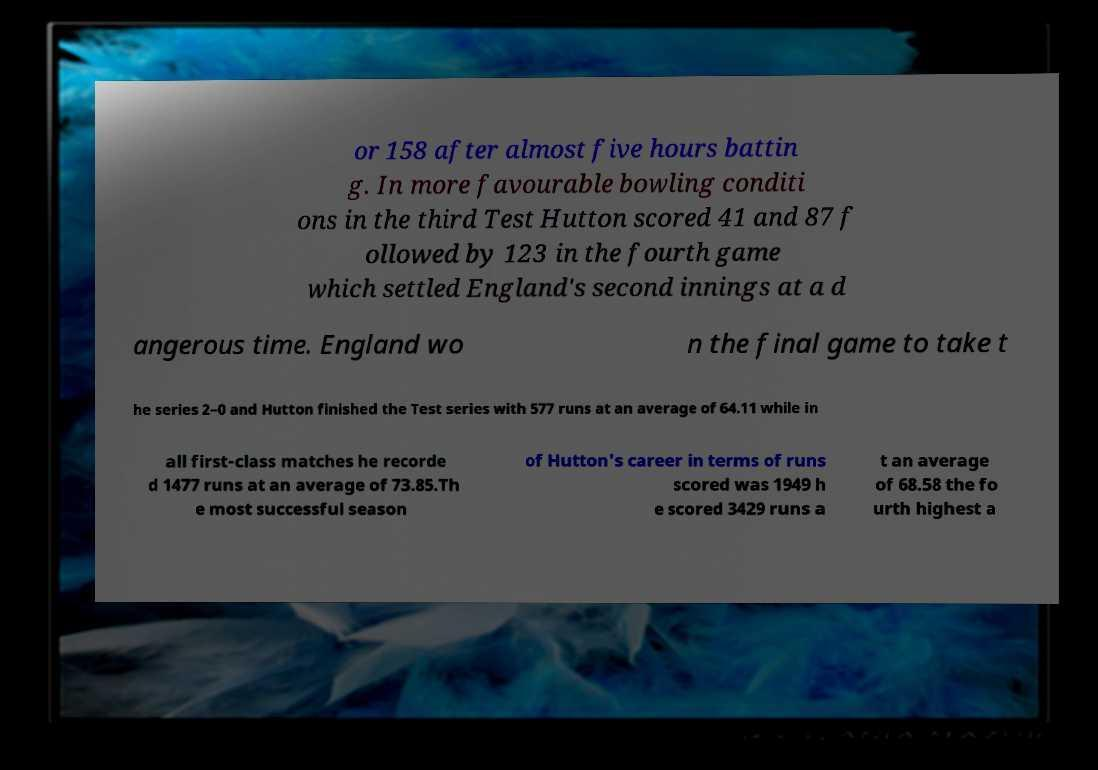Please read and relay the text visible in this image. What does it say? or 158 after almost five hours battin g. In more favourable bowling conditi ons in the third Test Hutton scored 41 and 87 f ollowed by 123 in the fourth game which settled England's second innings at a d angerous time. England wo n the final game to take t he series 2–0 and Hutton finished the Test series with 577 runs at an average of 64.11 while in all first-class matches he recorde d 1477 runs at an average of 73.85.Th e most successful season of Hutton's career in terms of runs scored was 1949 h e scored 3429 runs a t an average of 68.58 the fo urth highest a 